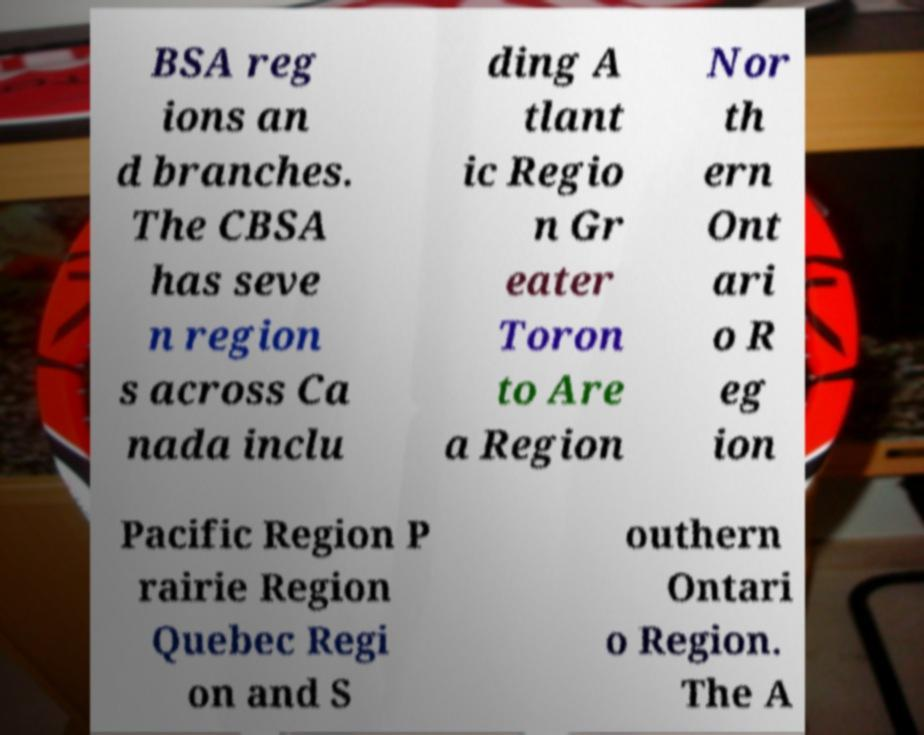What messages or text are displayed in this image? I need them in a readable, typed format. BSA reg ions an d branches. The CBSA has seve n region s across Ca nada inclu ding A tlant ic Regio n Gr eater Toron to Are a Region Nor th ern Ont ari o R eg ion Pacific Region P rairie Region Quebec Regi on and S outhern Ontari o Region. The A 